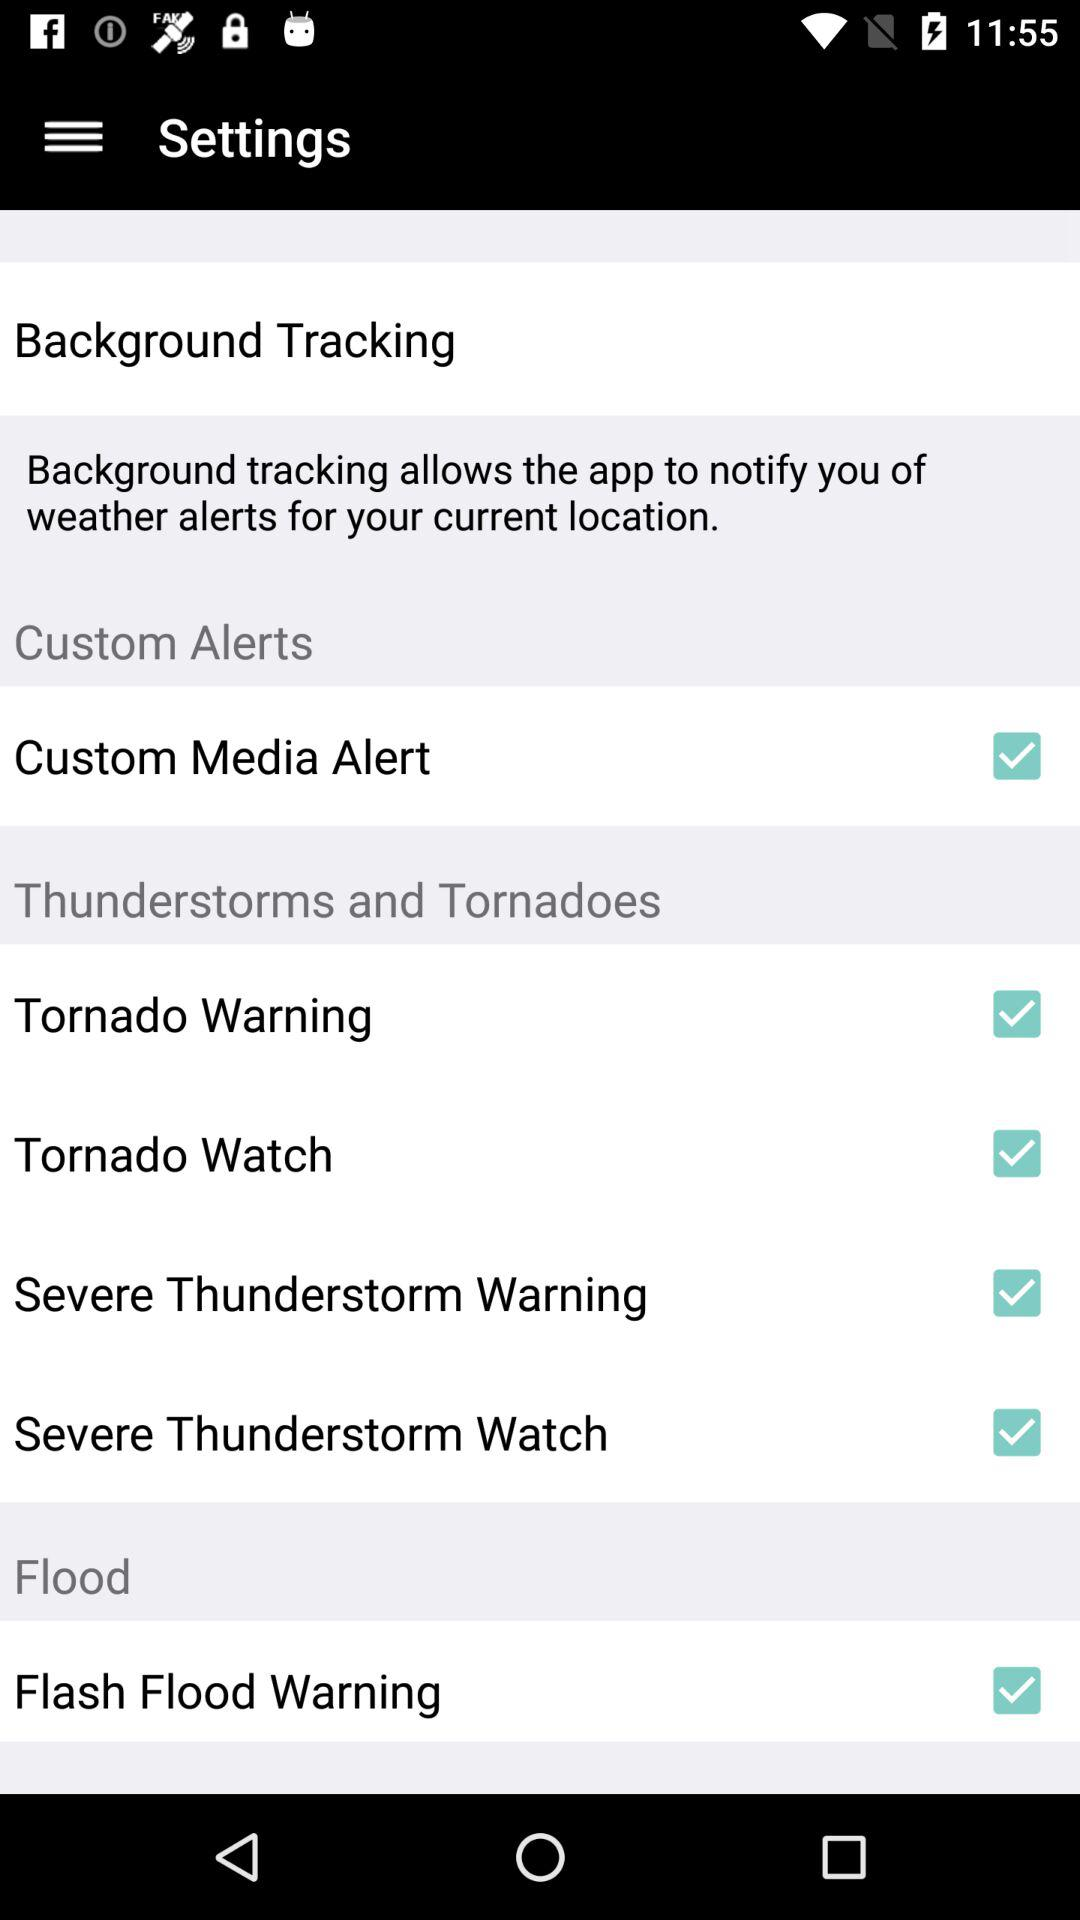What is the status of Tornado Watch? The status of Tornado Watch is "on". 